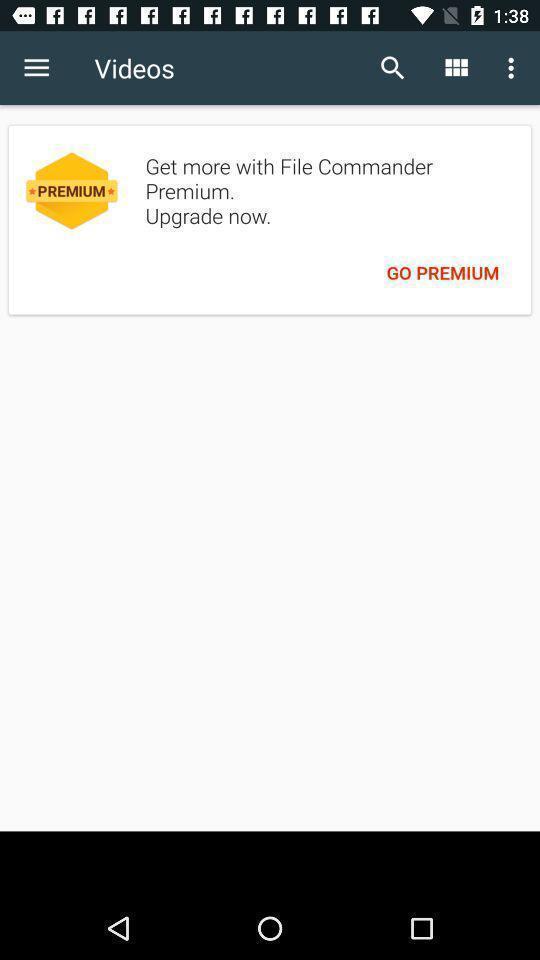Provide a description of this screenshot. Videos page. 